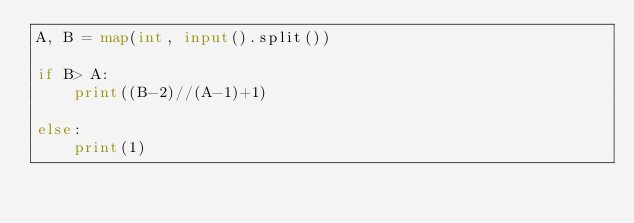Convert code to text. <code><loc_0><loc_0><loc_500><loc_500><_Python_>A, B = map(int, input().split())

if B> A:
	print((B-2)//(A-1)+1)
  
else:
	print(1)</code> 